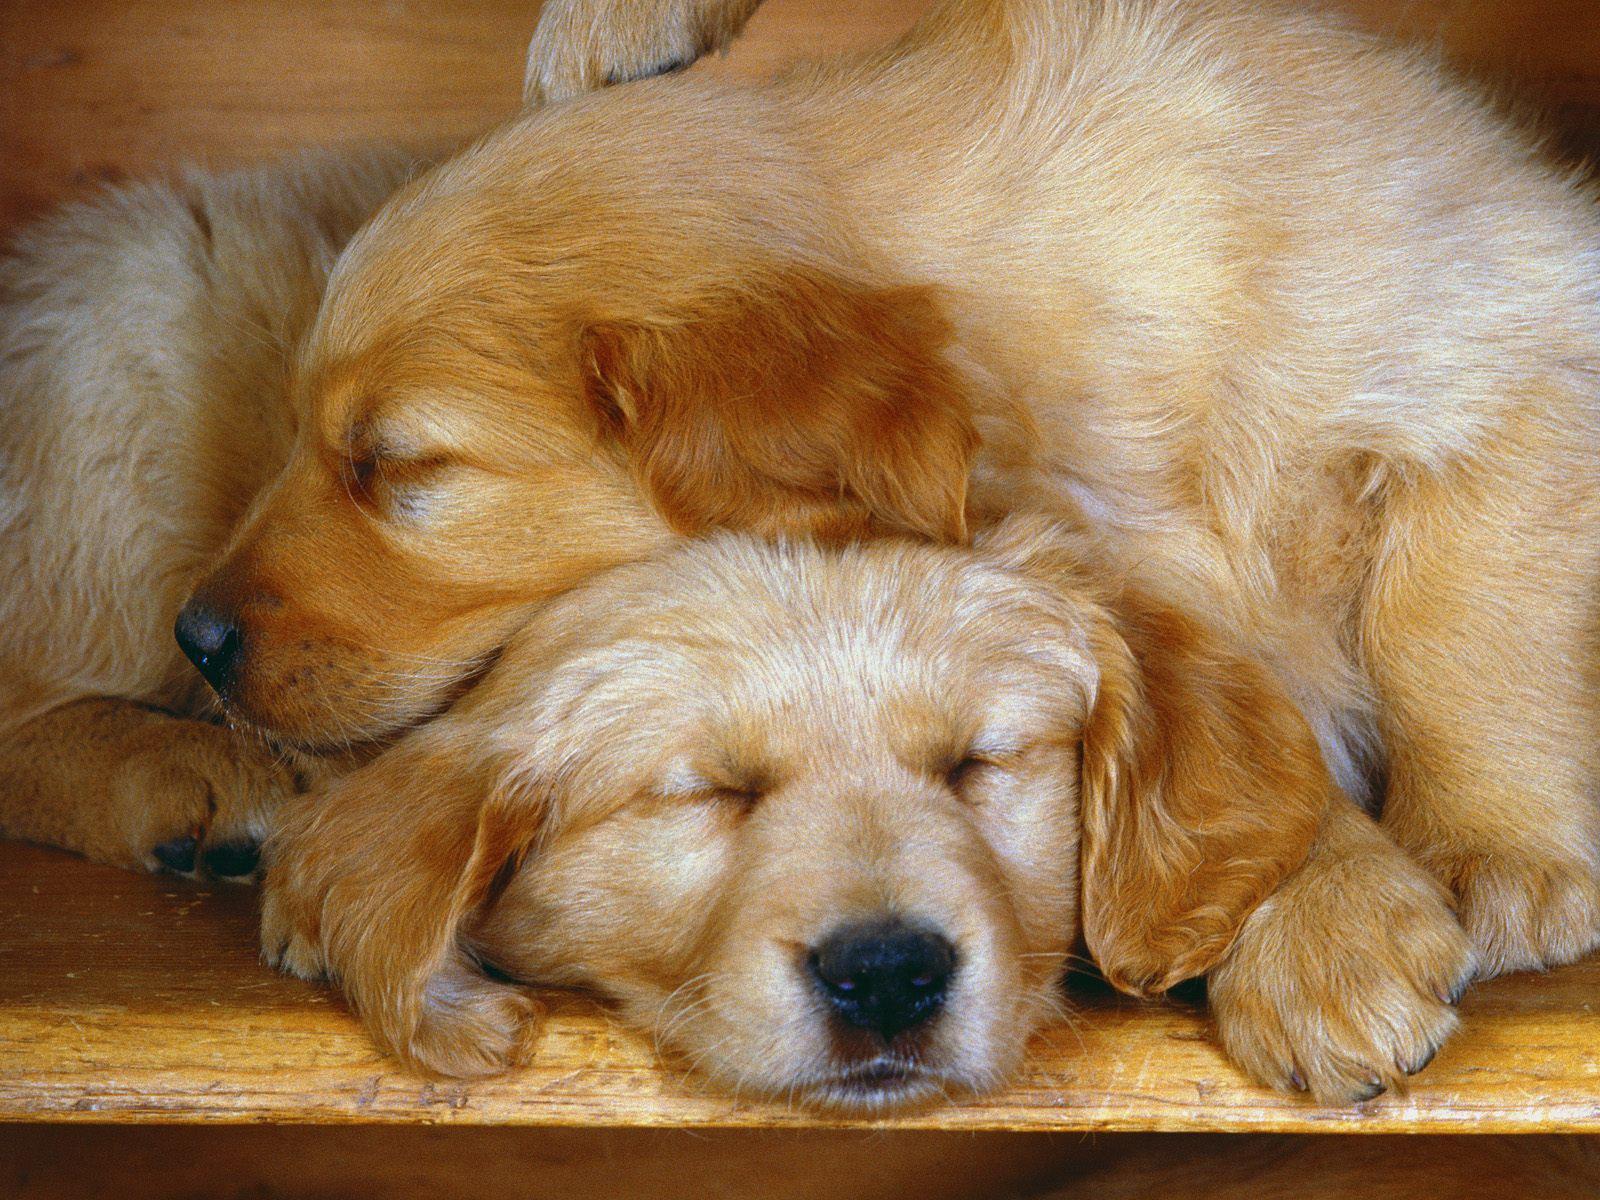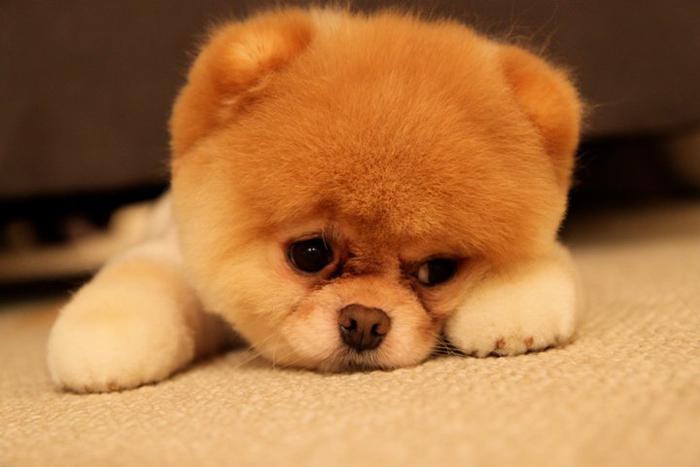The first image is the image on the left, the second image is the image on the right. Assess this claim about the two images: "Two dogs of similar coloring are snoozing with heads touching on a wood-grained surface.". Correct or not? Answer yes or no. Yes. The first image is the image on the left, the second image is the image on the right. Analyze the images presented: Is the assertion "some dogs are sleeping and some are not." valid? Answer yes or no. Yes. 